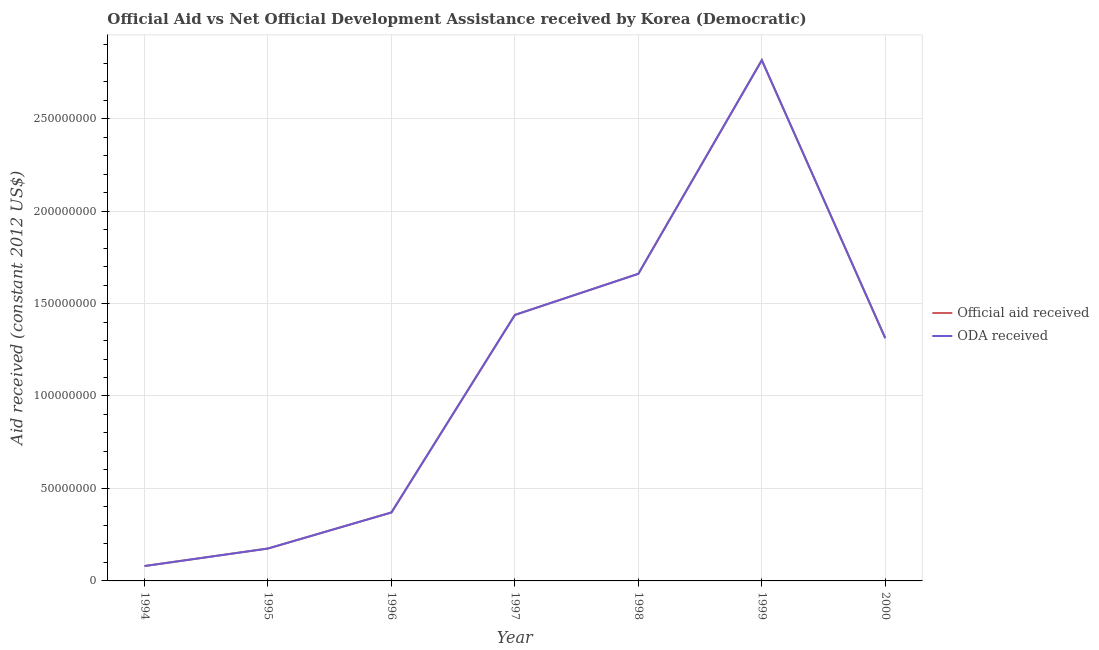What is the oda received in 2000?
Your answer should be compact. 1.31e+08. Across all years, what is the maximum oda received?
Your response must be concise. 2.82e+08. Across all years, what is the minimum official aid received?
Ensure brevity in your answer.  8.05e+06. In which year was the oda received minimum?
Your response must be concise. 1994. What is the total official aid received in the graph?
Your response must be concise. 7.85e+08. What is the difference between the official aid received in 1996 and that in 2000?
Provide a succinct answer. -9.42e+07. What is the difference between the official aid received in 2000 and the oda received in 1995?
Provide a short and direct response. 1.14e+08. What is the average oda received per year?
Keep it short and to the point. 1.12e+08. In the year 1999, what is the difference between the oda received and official aid received?
Offer a very short reply. 0. In how many years, is the oda received greater than 220000000 US$?
Your answer should be compact. 1. What is the ratio of the oda received in 1999 to that in 2000?
Offer a very short reply. 2.15. Is the difference between the official aid received in 1995 and 1997 greater than the difference between the oda received in 1995 and 1997?
Offer a terse response. No. What is the difference between the highest and the second highest official aid received?
Provide a short and direct response. 1.16e+08. What is the difference between the highest and the lowest oda received?
Provide a succinct answer. 2.74e+08. In how many years, is the official aid received greater than the average official aid received taken over all years?
Your answer should be compact. 4. Is the sum of the official aid received in 1996 and 1998 greater than the maximum oda received across all years?
Keep it short and to the point. No. Is the oda received strictly greater than the official aid received over the years?
Your response must be concise. No. How many lines are there?
Provide a short and direct response. 2. What is the difference between two consecutive major ticks on the Y-axis?
Your answer should be very brief. 5.00e+07. Are the values on the major ticks of Y-axis written in scientific E-notation?
Your response must be concise. No. Does the graph contain any zero values?
Provide a succinct answer. No. Does the graph contain grids?
Offer a very short reply. Yes. How many legend labels are there?
Your answer should be very brief. 2. What is the title of the graph?
Keep it short and to the point. Official Aid vs Net Official Development Assistance received by Korea (Democratic) . Does "Highest 20% of population" appear as one of the legend labels in the graph?
Provide a short and direct response. No. What is the label or title of the Y-axis?
Offer a terse response. Aid received (constant 2012 US$). What is the Aid received (constant 2012 US$) of Official aid received in 1994?
Make the answer very short. 8.05e+06. What is the Aid received (constant 2012 US$) of ODA received in 1994?
Your answer should be compact. 8.05e+06. What is the Aid received (constant 2012 US$) of Official aid received in 1995?
Make the answer very short. 1.75e+07. What is the Aid received (constant 2012 US$) of ODA received in 1995?
Your response must be concise. 1.75e+07. What is the Aid received (constant 2012 US$) of Official aid received in 1996?
Your answer should be very brief. 3.70e+07. What is the Aid received (constant 2012 US$) of ODA received in 1996?
Offer a terse response. 3.70e+07. What is the Aid received (constant 2012 US$) in Official aid received in 1997?
Provide a short and direct response. 1.44e+08. What is the Aid received (constant 2012 US$) in ODA received in 1997?
Offer a very short reply. 1.44e+08. What is the Aid received (constant 2012 US$) in Official aid received in 1998?
Offer a very short reply. 1.66e+08. What is the Aid received (constant 2012 US$) in ODA received in 1998?
Offer a very short reply. 1.66e+08. What is the Aid received (constant 2012 US$) in Official aid received in 1999?
Offer a very short reply. 2.82e+08. What is the Aid received (constant 2012 US$) of ODA received in 1999?
Your answer should be very brief. 2.82e+08. What is the Aid received (constant 2012 US$) of Official aid received in 2000?
Your response must be concise. 1.31e+08. What is the Aid received (constant 2012 US$) of ODA received in 2000?
Offer a very short reply. 1.31e+08. Across all years, what is the maximum Aid received (constant 2012 US$) of Official aid received?
Offer a terse response. 2.82e+08. Across all years, what is the maximum Aid received (constant 2012 US$) of ODA received?
Provide a short and direct response. 2.82e+08. Across all years, what is the minimum Aid received (constant 2012 US$) of Official aid received?
Your answer should be very brief. 8.05e+06. Across all years, what is the minimum Aid received (constant 2012 US$) in ODA received?
Give a very brief answer. 8.05e+06. What is the total Aid received (constant 2012 US$) of Official aid received in the graph?
Offer a terse response. 7.85e+08. What is the total Aid received (constant 2012 US$) of ODA received in the graph?
Provide a short and direct response. 7.85e+08. What is the difference between the Aid received (constant 2012 US$) in Official aid received in 1994 and that in 1995?
Your response must be concise. -9.47e+06. What is the difference between the Aid received (constant 2012 US$) in ODA received in 1994 and that in 1995?
Provide a succinct answer. -9.47e+06. What is the difference between the Aid received (constant 2012 US$) of Official aid received in 1994 and that in 1996?
Your answer should be very brief. -2.90e+07. What is the difference between the Aid received (constant 2012 US$) in ODA received in 1994 and that in 1996?
Offer a very short reply. -2.90e+07. What is the difference between the Aid received (constant 2012 US$) in Official aid received in 1994 and that in 1997?
Make the answer very short. -1.36e+08. What is the difference between the Aid received (constant 2012 US$) of ODA received in 1994 and that in 1997?
Provide a short and direct response. -1.36e+08. What is the difference between the Aid received (constant 2012 US$) in Official aid received in 1994 and that in 1998?
Ensure brevity in your answer.  -1.58e+08. What is the difference between the Aid received (constant 2012 US$) in ODA received in 1994 and that in 1998?
Your answer should be very brief. -1.58e+08. What is the difference between the Aid received (constant 2012 US$) in Official aid received in 1994 and that in 1999?
Your answer should be compact. -2.74e+08. What is the difference between the Aid received (constant 2012 US$) in ODA received in 1994 and that in 1999?
Offer a terse response. -2.74e+08. What is the difference between the Aid received (constant 2012 US$) in Official aid received in 1994 and that in 2000?
Make the answer very short. -1.23e+08. What is the difference between the Aid received (constant 2012 US$) in ODA received in 1994 and that in 2000?
Keep it short and to the point. -1.23e+08. What is the difference between the Aid received (constant 2012 US$) in Official aid received in 1995 and that in 1996?
Your answer should be compact. -1.95e+07. What is the difference between the Aid received (constant 2012 US$) of ODA received in 1995 and that in 1996?
Make the answer very short. -1.95e+07. What is the difference between the Aid received (constant 2012 US$) in Official aid received in 1995 and that in 1997?
Your response must be concise. -1.26e+08. What is the difference between the Aid received (constant 2012 US$) of ODA received in 1995 and that in 1997?
Give a very brief answer. -1.26e+08. What is the difference between the Aid received (constant 2012 US$) in Official aid received in 1995 and that in 1998?
Provide a short and direct response. -1.49e+08. What is the difference between the Aid received (constant 2012 US$) of ODA received in 1995 and that in 1998?
Make the answer very short. -1.49e+08. What is the difference between the Aid received (constant 2012 US$) of Official aid received in 1995 and that in 1999?
Keep it short and to the point. -2.64e+08. What is the difference between the Aid received (constant 2012 US$) in ODA received in 1995 and that in 1999?
Provide a short and direct response. -2.64e+08. What is the difference between the Aid received (constant 2012 US$) of Official aid received in 1995 and that in 2000?
Give a very brief answer. -1.14e+08. What is the difference between the Aid received (constant 2012 US$) of ODA received in 1995 and that in 2000?
Offer a very short reply. -1.14e+08. What is the difference between the Aid received (constant 2012 US$) in Official aid received in 1996 and that in 1997?
Offer a terse response. -1.07e+08. What is the difference between the Aid received (constant 2012 US$) in ODA received in 1996 and that in 1997?
Ensure brevity in your answer.  -1.07e+08. What is the difference between the Aid received (constant 2012 US$) of Official aid received in 1996 and that in 1998?
Your answer should be compact. -1.29e+08. What is the difference between the Aid received (constant 2012 US$) of ODA received in 1996 and that in 1998?
Keep it short and to the point. -1.29e+08. What is the difference between the Aid received (constant 2012 US$) of Official aid received in 1996 and that in 1999?
Provide a short and direct response. -2.45e+08. What is the difference between the Aid received (constant 2012 US$) of ODA received in 1996 and that in 1999?
Provide a succinct answer. -2.45e+08. What is the difference between the Aid received (constant 2012 US$) of Official aid received in 1996 and that in 2000?
Keep it short and to the point. -9.42e+07. What is the difference between the Aid received (constant 2012 US$) of ODA received in 1996 and that in 2000?
Give a very brief answer. -9.42e+07. What is the difference between the Aid received (constant 2012 US$) of Official aid received in 1997 and that in 1998?
Your answer should be very brief. -2.22e+07. What is the difference between the Aid received (constant 2012 US$) in ODA received in 1997 and that in 1998?
Keep it short and to the point. -2.22e+07. What is the difference between the Aid received (constant 2012 US$) of Official aid received in 1997 and that in 1999?
Give a very brief answer. -1.38e+08. What is the difference between the Aid received (constant 2012 US$) of ODA received in 1997 and that in 1999?
Make the answer very short. -1.38e+08. What is the difference between the Aid received (constant 2012 US$) of Official aid received in 1997 and that in 2000?
Give a very brief answer. 1.26e+07. What is the difference between the Aid received (constant 2012 US$) in ODA received in 1997 and that in 2000?
Offer a very short reply. 1.26e+07. What is the difference between the Aid received (constant 2012 US$) of Official aid received in 1998 and that in 1999?
Give a very brief answer. -1.16e+08. What is the difference between the Aid received (constant 2012 US$) of ODA received in 1998 and that in 1999?
Ensure brevity in your answer.  -1.16e+08. What is the difference between the Aid received (constant 2012 US$) in Official aid received in 1998 and that in 2000?
Your answer should be very brief. 3.48e+07. What is the difference between the Aid received (constant 2012 US$) of ODA received in 1998 and that in 2000?
Provide a succinct answer. 3.48e+07. What is the difference between the Aid received (constant 2012 US$) of Official aid received in 1999 and that in 2000?
Offer a very short reply. 1.50e+08. What is the difference between the Aid received (constant 2012 US$) of ODA received in 1999 and that in 2000?
Make the answer very short. 1.50e+08. What is the difference between the Aid received (constant 2012 US$) of Official aid received in 1994 and the Aid received (constant 2012 US$) of ODA received in 1995?
Provide a succinct answer. -9.47e+06. What is the difference between the Aid received (constant 2012 US$) of Official aid received in 1994 and the Aid received (constant 2012 US$) of ODA received in 1996?
Provide a short and direct response. -2.90e+07. What is the difference between the Aid received (constant 2012 US$) in Official aid received in 1994 and the Aid received (constant 2012 US$) in ODA received in 1997?
Give a very brief answer. -1.36e+08. What is the difference between the Aid received (constant 2012 US$) in Official aid received in 1994 and the Aid received (constant 2012 US$) in ODA received in 1998?
Provide a short and direct response. -1.58e+08. What is the difference between the Aid received (constant 2012 US$) in Official aid received in 1994 and the Aid received (constant 2012 US$) in ODA received in 1999?
Make the answer very short. -2.74e+08. What is the difference between the Aid received (constant 2012 US$) in Official aid received in 1994 and the Aid received (constant 2012 US$) in ODA received in 2000?
Offer a very short reply. -1.23e+08. What is the difference between the Aid received (constant 2012 US$) of Official aid received in 1995 and the Aid received (constant 2012 US$) of ODA received in 1996?
Give a very brief answer. -1.95e+07. What is the difference between the Aid received (constant 2012 US$) in Official aid received in 1995 and the Aid received (constant 2012 US$) in ODA received in 1997?
Ensure brevity in your answer.  -1.26e+08. What is the difference between the Aid received (constant 2012 US$) of Official aid received in 1995 and the Aid received (constant 2012 US$) of ODA received in 1998?
Ensure brevity in your answer.  -1.49e+08. What is the difference between the Aid received (constant 2012 US$) of Official aid received in 1995 and the Aid received (constant 2012 US$) of ODA received in 1999?
Provide a short and direct response. -2.64e+08. What is the difference between the Aid received (constant 2012 US$) in Official aid received in 1995 and the Aid received (constant 2012 US$) in ODA received in 2000?
Ensure brevity in your answer.  -1.14e+08. What is the difference between the Aid received (constant 2012 US$) in Official aid received in 1996 and the Aid received (constant 2012 US$) in ODA received in 1997?
Ensure brevity in your answer.  -1.07e+08. What is the difference between the Aid received (constant 2012 US$) of Official aid received in 1996 and the Aid received (constant 2012 US$) of ODA received in 1998?
Make the answer very short. -1.29e+08. What is the difference between the Aid received (constant 2012 US$) of Official aid received in 1996 and the Aid received (constant 2012 US$) of ODA received in 1999?
Provide a succinct answer. -2.45e+08. What is the difference between the Aid received (constant 2012 US$) in Official aid received in 1996 and the Aid received (constant 2012 US$) in ODA received in 2000?
Make the answer very short. -9.42e+07. What is the difference between the Aid received (constant 2012 US$) of Official aid received in 1997 and the Aid received (constant 2012 US$) of ODA received in 1998?
Offer a terse response. -2.22e+07. What is the difference between the Aid received (constant 2012 US$) of Official aid received in 1997 and the Aid received (constant 2012 US$) of ODA received in 1999?
Offer a very short reply. -1.38e+08. What is the difference between the Aid received (constant 2012 US$) of Official aid received in 1997 and the Aid received (constant 2012 US$) of ODA received in 2000?
Make the answer very short. 1.26e+07. What is the difference between the Aid received (constant 2012 US$) of Official aid received in 1998 and the Aid received (constant 2012 US$) of ODA received in 1999?
Provide a succinct answer. -1.16e+08. What is the difference between the Aid received (constant 2012 US$) in Official aid received in 1998 and the Aid received (constant 2012 US$) in ODA received in 2000?
Keep it short and to the point. 3.48e+07. What is the difference between the Aid received (constant 2012 US$) of Official aid received in 1999 and the Aid received (constant 2012 US$) of ODA received in 2000?
Provide a succinct answer. 1.50e+08. What is the average Aid received (constant 2012 US$) of Official aid received per year?
Provide a succinct answer. 1.12e+08. What is the average Aid received (constant 2012 US$) of ODA received per year?
Ensure brevity in your answer.  1.12e+08. In the year 1995, what is the difference between the Aid received (constant 2012 US$) of Official aid received and Aid received (constant 2012 US$) of ODA received?
Your answer should be very brief. 0. In the year 1999, what is the difference between the Aid received (constant 2012 US$) in Official aid received and Aid received (constant 2012 US$) in ODA received?
Keep it short and to the point. 0. What is the ratio of the Aid received (constant 2012 US$) in Official aid received in 1994 to that in 1995?
Provide a succinct answer. 0.46. What is the ratio of the Aid received (constant 2012 US$) in ODA received in 1994 to that in 1995?
Make the answer very short. 0.46. What is the ratio of the Aid received (constant 2012 US$) of Official aid received in 1994 to that in 1996?
Offer a terse response. 0.22. What is the ratio of the Aid received (constant 2012 US$) in ODA received in 1994 to that in 1996?
Your response must be concise. 0.22. What is the ratio of the Aid received (constant 2012 US$) in Official aid received in 1994 to that in 1997?
Offer a terse response. 0.06. What is the ratio of the Aid received (constant 2012 US$) of ODA received in 1994 to that in 1997?
Provide a succinct answer. 0.06. What is the ratio of the Aid received (constant 2012 US$) in Official aid received in 1994 to that in 1998?
Ensure brevity in your answer.  0.05. What is the ratio of the Aid received (constant 2012 US$) in ODA received in 1994 to that in 1998?
Give a very brief answer. 0.05. What is the ratio of the Aid received (constant 2012 US$) of Official aid received in 1994 to that in 1999?
Make the answer very short. 0.03. What is the ratio of the Aid received (constant 2012 US$) in ODA received in 1994 to that in 1999?
Your answer should be very brief. 0.03. What is the ratio of the Aid received (constant 2012 US$) of Official aid received in 1994 to that in 2000?
Give a very brief answer. 0.06. What is the ratio of the Aid received (constant 2012 US$) of ODA received in 1994 to that in 2000?
Your response must be concise. 0.06. What is the ratio of the Aid received (constant 2012 US$) in Official aid received in 1995 to that in 1996?
Provide a succinct answer. 0.47. What is the ratio of the Aid received (constant 2012 US$) in ODA received in 1995 to that in 1996?
Your response must be concise. 0.47. What is the ratio of the Aid received (constant 2012 US$) of Official aid received in 1995 to that in 1997?
Give a very brief answer. 0.12. What is the ratio of the Aid received (constant 2012 US$) of ODA received in 1995 to that in 1997?
Make the answer very short. 0.12. What is the ratio of the Aid received (constant 2012 US$) of Official aid received in 1995 to that in 1998?
Offer a very short reply. 0.11. What is the ratio of the Aid received (constant 2012 US$) of ODA received in 1995 to that in 1998?
Keep it short and to the point. 0.11. What is the ratio of the Aid received (constant 2012 US$) of Official aid received in 1995 to that in 1999?
Ensure brevity in your answer.  0.06. What is the ratio of the Aid received (constant 2012 US$) of ODA received in 1995 to that in 1999?
Make the answer very short. 0.06. What is the ratio of the Aid received (constant 2012 US$) of Official aid received in 1995 to that in 2000?
Provide a short and direct response. 0.13. What is the ratio of the Aid received (constant 2012 US$) of ODA received in 1995 to that in 2000?
Your answer should be compact. 0.13. What is the ratio of the Aid received (constant 2012 US$) in Official aid received in 1996 to that in 1997?
Give a very brief answer. 0.26. What is the ratio of the Aid received (constant 2012 US$) in ODA received in 1996 to that in 1997?
Make the answer very short. 0.26. What is the ratio of the Aid received (constant 2012 US$) in Official aid received in 1996 to that in 1998?
Provide a short and direct response. 0.22. What is the ratio of the Aid received (constant 2012 US$) of ODA received in 1996 to that in 1998?
Offer a terse response. 0.22. What is the ratio of the Aid received (constant 2012 US$) of Official aid received in 1996 to that in 1999?
Provide a short and direct response. 0.13. What is the ratio of the Aid received (constant 2012 US$) of ODA received in 1996 to that in 1999?
Ensure brevity in your answer.  0.13. What is the ratio of the Aid received (constant 2012 US$) of Official aid received in 1996 to that in 2000?
Your answer should be very brief. 0.28. What is the ratio of the Aid received (constant 2012 US$) in ODA received in 1996 to that in 2000?
Keep it short and to the point. 0.28. What is the ratio of the Aid received (constant 2012 US$) of Official aid received in 1997 to that in 1998?
Your response must be concise. 0.87. What is the ratio of the Aid received (constant 2012 US$) of ODA received in 1997 to that in 1998?
Ensure brevity in your answer.  0.87. What is the ratio of the Aid received (constant 2012 US$) in Official aid received in 1997 to that in 1999?
Your response must be concise. 0.51. What is the ratio of the Aid received (constant 2012 US$) of ODA received in 1997 to that in 1999?
Your answer should be compact. 0.51. What is the ratio of the Aid received (constant 2012 US$) in Official aid received in 1997 to that in 2000?
Offer a very short reply. 1.1. What is the ratio of the Aid received (constant 2012 US$) in ODA received in 1997 to that in 2000?
Your response must be concise. 1.1. What is the ratio of the Aid received (constant 2012 US$) in Official aid received in 1998 to that in 1999?
Provide a short and direct response. 0.59. What is the ratio of the Aid received (constant 2012 US$) of ODA received in 1998 to that in 1999?
Offer a terse response. 0.59. What is the ratio of the Aid received (constant 2012 US$) in Official aid received in 1998 to that in 2000?
Provide a short and direct response. 1.27. What is the ratio of the Aid received (constant 2012 US$) in ODA received in 1998 to that in 2000?
Offer a terse response. 1.27. What is the ratio of the Aid received (constant 2012 US$) in Official aid received in 1999 to that in 2000?
Your answer should be compact. 2.15. What is the ratio of the Aid received (constant 2012 US$) in ODA received in 1999 to that in 2000?
Provide a short and direct response. 2.15. What is the difference between the highest and the second highest Aid received (constant 2012 US$) of Official aid received?
Provide a short and direct response. 1.16e+08. What is the difference between the highest and the second highest Aid received (constant 2012 US$) in ODA received?
Give a very brief answer. 1.16e+08. What is the difference between the highest and the lowest Aid received (constant 2012 US$) of Official aid received?
Offer a terse response. 2.74e+08. What is the difference between the highest and the lowest Aid received (constant 2012 US$) of ODA received?
Make the answer very short. 2.74e+08. 